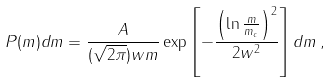Convert formula to latex. <formula><loc_0><loc_0><loc_500><loc_500>P ( m ) d m = \frac { A } { ( \sqrt { 2 \pi } ) w m } \exp \left [ - \frac { \left ( \ln \frac { m } { m _ { c } } \right ) ^ { 2 } } { 2 w ^ { 2 } } \right ] d m \, ,</formula> 